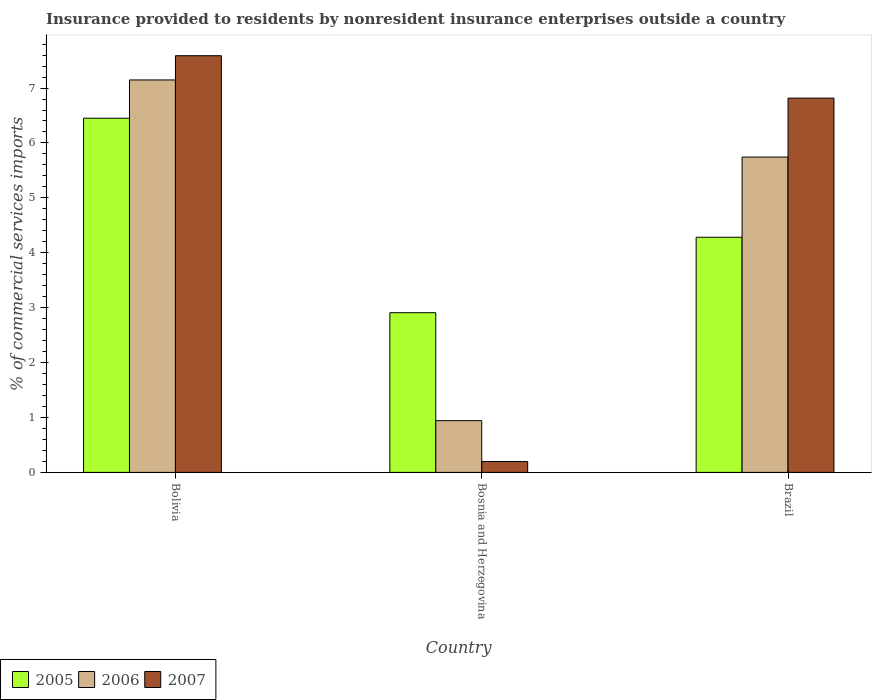How many different coloured bars are there?
Your answer should be compact. 3. What is the Insurance provided to residents in 2005 in Bosnia and Herzegovina?
Your answer should be compact. 2.91. Across all countries, what is the maximum Insurance provided to residents in 2005?
Make the answer very short. 6.45. Across all countries, what is the minimum Insurance provided to residents in 2007?
Provide a succinct answer. 0.2. In which country was the Insurance provided to residents in 2005 minimum?
Provide a short and direct response. Bosnia and Herzegovina. What is the total Insurance provided to residents in 2007 in the graph?
Make the answer very short. 14.6. What is the difference between the Insurance provided to residents in 2006 in Bolivia and that in Bosnia and Herzegovina?
Provide a short and direct response. 6.21. What is the difference between the Insurance provided to residents in 2006 in Bolivia and the Insurance provided to residents in 2005 in Brazil?
Make the answer very short. 2.87. What is the average Insurance provided to residents in 2006 per country?
Your answer should be compact. 4.61. What is the difference between the Insurance provided to residents of/in 2007 and Insurance provided to residents of/in 2006 in Brazil?
Your response must be concise. 1.07. In how many countries, is the Insurance provided to residents in 2006 greater than 2.8 %?
Ensure brevity in your answer.  2. What is the ratio of the Insurance provided to residents in 2007 in Bolivia to that in Bosnia and Herzegovina?
Provide a succinct answer. 38.43. Is the difference between the Insurance provided to residents in 2007 in Bolivia and Brazil greater than the difference between the Insurance provided to residents in 2006 in Bolivia and Brazil?
Keep it short and to the point. No. What is the difference between the highest and the second highest Insurance provided to residents in 2006?
Keep it short and to the point. -4.8. What is the difference between the highest and the lowest Insurance provided to residents in 2007?
Provide a succinct answer. 7.39. Is the sum of the Insurance provided to residents in 2006 in Bolivia and Brazil greater than the maximum Insurance provided to residents in 2007 across all countries?
Give a very brief answer. Yes. What does the 2nd bar from the left in Bosnia and Herzegovina represents?
Keep it short and to the point. 2006. How many bars are there?
Provide a short and direct response. 9. Are the values on the major ticks of Y-axis written in scientific E-notation?
Ensure brevity in your answer.  No. Does the graph contain any zero values?
Make the answer very short. No. Does the graph contain grids?
Make the answer very short. No. What is the title of the graph?
Ensure brevity in your answer.  Insurance provided to residents by nonresident insurance enterprises outside a country. What is the label or title of the X-axis?
Make the answer very short. Country. What is the label or title of the Y-axis?
Your response must be concise. % of commercial services imports. What is the % of commercial services imports in 2005 in Bolivia?
Keep it short and to the point. 6.45. What is the % of commercial services imports in 2006 in Bolivia?
Keep it short and to the point. 7.15. What is the % of commercial services imports of 2007 in Bolivia?
Ensure brevity in your answer.  7.59. What is the % of commercial services imports of 2005 in Bosnia and Herzegovina?
Your response must be concise. 2.91. What is the % of commercial services imports of 2006 in Bosnia and Herzegovina?
Provide a short and direct response. 0.94. What is the % of commercial services imports in 2007 in Bosnia and Herzegovina?
Provide a succinct answer. 0.2. What is the % of commercial services imports in 2005 in Brazil?
Make the answer very short. 4.28. What is the % of commercial services imports of 2006 in Brazil?
Give a very brief answer. 5.74. What is the % of commercial services imports of 2007 in Brazil?
Keep it short and to the point. 6.82. Across all countries, what is the maximum % of commercial services imports of 2005?
Offer a terse response. 6.45. Across all countries, what is the maximum % of commercial services imports of 2006?
Keep it short and to the point. 7.15. Across all countries, what is the maximum % of commercial services imports of 2007?
Your answer should be very brief. 7.59. Across all countries, what is the minimum % of commercial services imports in 2005?
Keep it short and to the point. 2.91. Across all countries, what is the minimum % of commercial services imports of 2006?
Keep it short and to the point. 0.94. Across all countries, what is the minimum % of commercial services imports of 2007?
Provide a succinct answer. 0.2. What is the total % of commercial services imports in 2005 in the graph?
Provide a short and direct response. 13.64. What is the total % of commercial services imports in 2006 in the graph?
Make the answer very short. 13.83. What is the total % of commercial services imports in 2007 in the graph?
Make the answer very short. 14.6. What is the difference between the % of commercial services imports of 2005 in Bolivia and that in Bosnia and Herzegovina?
Provide a short and direct response. 3.54. What is the difference between the % of commercial services imports in 2006 in Bolivia and that in Bosnia and Herzegovina?
Make the answer very short. 6.21. What is the difference between the % of commercial services imports of 2007 in Bolivia and that in Bosnia and Herzegovina?
Give a very brief answer. 7.39. What is the difference between the % of commercial services imports of 2005 in Bolivia and that in Brazil?
Ensure brevity in your answer.  2.17. What is the difference between the % of commercial services imports in 2006 in Bolivia and that in Brazil?
Your answer should be very brief. 1.4. What is the difference between the % of commercial services imports in 2007 in Bolivia and that in Brazil?
Give a very brief answer. 0.77. What is the difference between the % of commercial services imports in 2005 in Bosnia and Herzegovina and that in Brazil?
Keep it short and to the point. -1.37. What is the difference between the % of commercial services imports of 2006 in Bosnia and Herzegovina and that in Brazil?
Provide a short and direct response. -4.8. What is the difference between the % of commercial services imports of 2007 in Bosnia and Herzegovina and that in Brazil?
Your answer should be very brief. -6.62. What is the difference between the % of commercial services imports in 2005 in Bolivia and the % of commercial services imports in 2006 in Bosnia and Herzegovina?
Provide a short and direct response. 5.51. What is the difference between the % of commercial services imports of 2005 in Bolivia and the % of commercial services imports of 2007 in Bosnia and Herzegovina?
Provide a short and direct response. 6.25. What is the difference between the % of commercial services imports in 2006 in Bolivia and the % of commercial services imports in 2007 in Bosnia and Herzegovina?
Offer a terse response. 6.95. What is the difference between the % of commercial services imports in 2005 in Bolivia and the % of commercial services imports in 2006 in Brazil?
Offer a very short reply. 0.71. What is the difference between the % of commercial services imports of 2005 in Bolivia and the % of commercial services imports of 2007 in Brazil?
Your answer should be compact. -0.37. What is the difference between the % of commercial services imports of 2006 in Bolivia and the % of commercial services imports of 2007 in Brazil?
Provide a short and direct response. 0.33. What is the difference between the % of commercial services imports of 2005 in Bosnia and Herzegovina and the % of commercial services imports of 2006 in Brazil?
Your response must be concise. -2.83. What is the difference between the % of commercial services imports of 2005 in Bosnia and Herzegovina and the % of commercial services imports of 2007 in Brazil?
Offer a terse response. -3.91. What is the difference between the % of commercial services imports of 2006 in Bosnia and Herzegovina and the % of commercial services imports of 2007 in Brazil?
Your answer should be very brief. -5.87. What is the average % of commercial services imports of 2005 per country?
Ensure brevity in your answer.  4.55. What is the average % of commercial services imports in 2006 per country?
Your answer should be compact. 4.61. What is the average % of commercial services imports of 2007 per country?
Your response must be concise. 4.87. What is the difference between the % of commercial services imports of 2005 and % of commercial services imports of 2006 in Bolivia?
Provide a succinct answer. -0.7. What is the difference between the % of commercial services imports in 2005 and % of commercial services imports in 2007 in Bolivia?
Provide a succinct answer. -1.14. What is the difference between the % of commercial services imports of 2006 and % of commercial services imports of 2007 in Bolivia?
Make the answer very short. -0.44. What is the difference between the % of commercial services imports of 2005 and % of commercial services imports of 2006 in Bosnia and Herzegovina?
Your response must be concise. 1.97. What is the difference between the % of commercial services imports of 2005 and % of commercial services imports of 2007 in Bosnia and Herzegovina?
Offer a terse response. 2.71. What is the difference between the % of commercial services imports in 2006 and % of commercial services imports in 2007 in Bosnia and Herzegovina?
Your answer should be compact. 0.74. What is the difference between the % of commercial services imports of 2005 and % of commercial services imports of 2006 in Brazil?
Offer a very short reply. -1.46. What is the difference between the % of commercial services imports in 2005 and % of commercial services imports in 2007 in Brazil?
Offer a very short reply. -2.53. What is the difference between the % of commercial services imports of 2006 and % of commercial services imports of 2007 in Brazil?
Offer a terse response. -1.07. What is the ratio of the % of commercial services imports of 2005 in Bolivia to that in Bosnia and Herzegovina?
Give a very brief answer. 2.22. What is the ratio of the % of commercial services imports of 2006 in Bolivia to that in Bosnia and Herzegovina?
Offer a terse response. 7.58. What is the ratio of the % of commercial services imports of 2007 in Bolivia to that in Bosnia and Herzegovina?
Make the answer very short. 38.43. What is the ratio of the % of commercial services imports of 2005 in Bolivia to that in Brazil?
Your answer should be compact. 1.51. What is the ratio of the % of commercial services imports in 2006 in Bolivia to that in Brazil?
Offer a terse response. 1.24. What is the ratio of the % of commercial services imports of 2007 in Bolivia to that in Brazil?
Make the answer very short. 1.11. What is the ratio of the % of commercial services imports of 2005 in Bosnia and Herzegovina to that in Brazil?
Ensure brevity in your answer.  0.68. What is the ratio of the % of commercial services imports in 2006 in Bosnia and Herzegovina to that in Brazil?
Your answer should be very brief. 0.16. What is the ratio of the % of commercial services imports in 2007 in Bosnia and Herzegovina to that in Brazil?
Give a very brief answer. 0.03. What is the difference between the highest and the second highest % of commercial services imports in 2005?
Your answer should be compact. 2.17. What is the difference between the highest and the second highest % of commercial services imports in 2006?
Offer a very short reply. 1.4. What is the difference between the highest and the second highest % of commercial services imports of 2007?
Your response must be concise. 0.77. What is the difference between the highest and the lowest % of commercial services imports of 2005?
Give a very brief answer. 3.54. What is the difference between the highest and the lowest % of commercial services imports of 2006?
Give a very brief answer. 6.21. What is the difference between the highest and the lowest % of commercial services imports in 2007?
Your response must be concise. 7.39. 